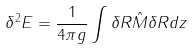Convert formula to latex. <formula><loc_0><loc_0><loc_500><loc_500>\delta ^ { 2 } E = \frac { 1 } { 4 \pi g } \int \delta R \hat { M } \delta R d z</formula> 